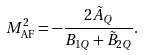Convert formula to latex. <formula><loc_0><loc_0><loc_500><loc_500>M _ { \text {AF} } ^ { 2 } = - \frac { 2 \tilde { A } _ { Q } } { B _ { 1 Q } + \tilde { B } _ { 2 Q } } .</formula> 